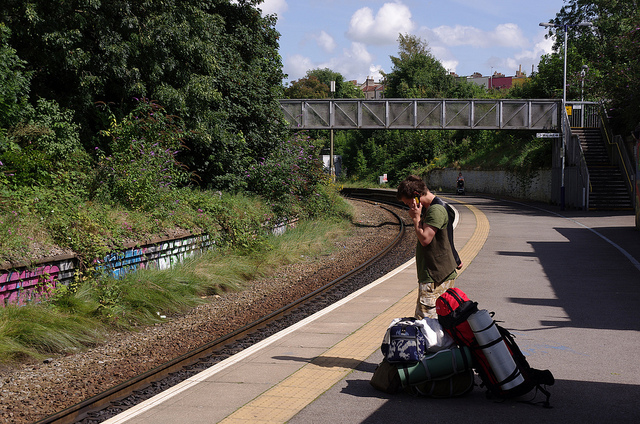Can you create a story where this image is the turning point of the plot? Absolutely! In the bustling city of Avenshire, Thomas stood on the platform, contemplating his next move. With a heavy backpack and a troubled expression, he was on the run—not from the law, but from a shadowy organization that had been experimenting on him and others. He had uncovered their secret: they were trying to harness supernatural abilities. Thomas's unusual strength and agility were the result of their experiments. As he waited, a coded message buzzed on his phone, instructing him to cross to the other side using the overhead bridge. From there, he would meet a contact who promised to help him expose the organization. The overhead bridge wasn't just a means to get to the other side of the tracks; it was his bridge to freedom and justice.  Visualize this station at night. How would it look and feel different? At night, the station would transform into a more serene but slightly eerie scene. The platform lights would cast long shadows, and the overhead bridge would be illuminated by soft, ambient lighting. The sound of distant trains would echo in the stillness. The dense trees and bushes nearby would add to the feeling of isolation, and any noise, such as rustling leaves or nocturnal animals, would seem amplified. The person on the platform might feel a heightened sense of caution or adventure as they wait in the quiet of the night.  Considering this is a real scenario, what might be some safe practices for the person to follow at the station? In a real scenario, some safe practices for the person at the station would include staying behind the yellow safety line while waiting for the train, using the overhead bridge to cross the tracks instead of attempting to walk across them directly, keeping personal belongings close and secure, being aware of their surroundings, and avoiding distractions such as mobile phones when near the tracks. 